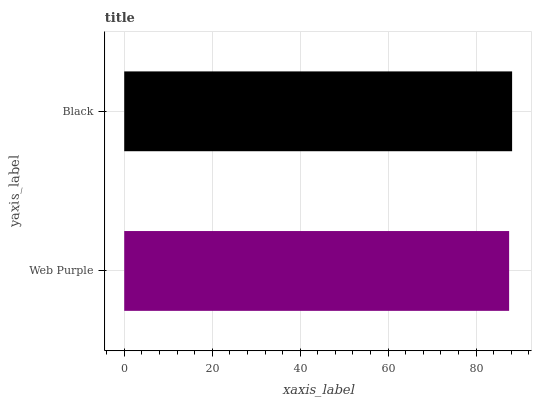Is Web Purple the minimum?
Answer yes or no. Yes. Is Black the maximum?
Answer yes or no. Yes. Is Black the minimum?
Answer yes or no. No. Is Black greater than Web Purple?
Answer yes or no. Yes. Is Web Purple less than Black?
Answer yes or no. Yes. Is Web Purple greater than Black?
Answer yes or no. No. Is Black less than Web Purple?
Answer yes or no. No. Is Black the high median?
Answer yes or no. Yes. Is Web Purple the low median?
Answer yes or no. Yes. Is Web Purple the high median?
Answer yes or no. No. Is Black the low median?
Answer yes or no. No. 